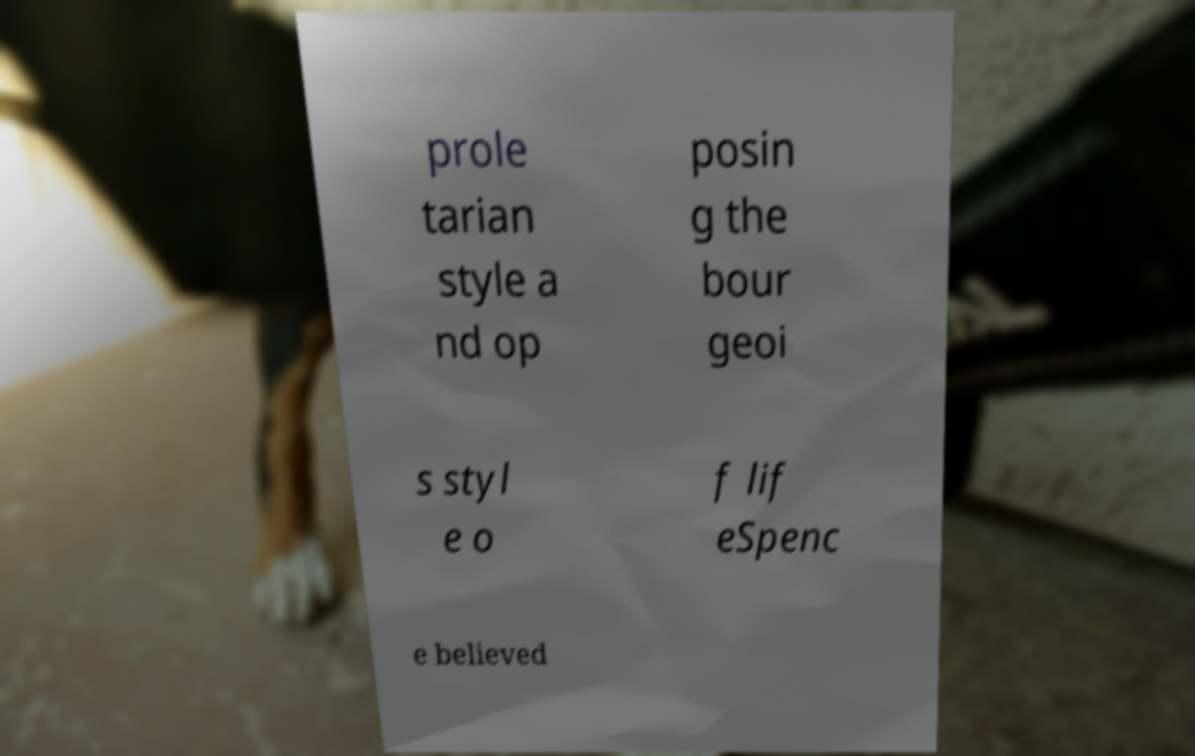I need the written content from this picture converted into text. Can you do that? prole tarian style a nd op posin g the bour geoi s styl e o f lif eSpenc e believed 